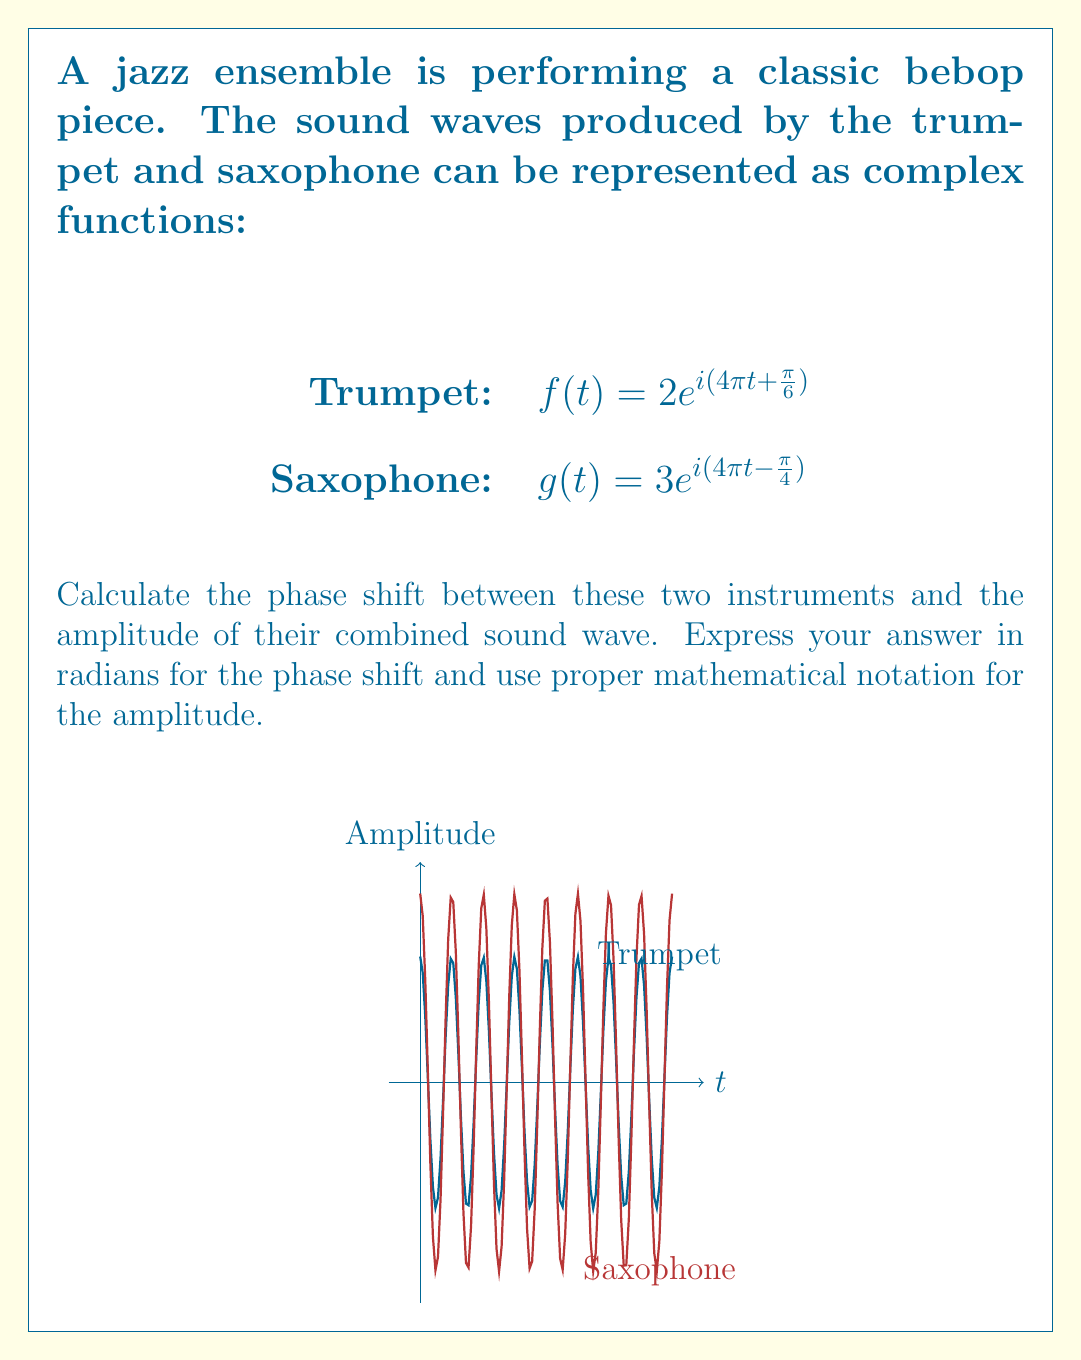Teach me how to tackle this problem. Let's approach this step-by-step:

1) Phase shift calculation:
   The phase of the trumpet wave is $4\pi t + \frac{\pi}{6}$
   The phase of the saxophone wave is $4\pi t - \frac{\pi}{4}$
   
   The phase shift is the difference between these phases:
   $$\Delta \phi = (\frac{\pi}{6}) - (-\frac{\pi}{4}) = \frac{\pi}{6} + \frac{\pi}{4} = \frac{5\pi}{12}$$

2) Amplitude calculation:
   To find the amplitude of the combined wave, we need to add the complex functions:
   
   $$h(t) = f(t) + g(t) = 2e^{i(4\pi t + \frac{\pi}{6})} + 3e^{i(4\pi t - \frac{\pi}{4})}$$
   
   We can factor out the common $e^{i4\pi t}$:
   
   $$h(t) = e^{i4\pi t}(2e^{i\frac{\pi}{6}} + 3e^{-i\frac{\pi}{4}})$$
   
   The amplitude of this combined wave is the magnitude of the complex number in parentheses:
   
   $$|2e^{i\frac{\pi}{6}} + 3e^{-i\frac{\pi}{4}}|$$
   
   We can calculate this using the formula $|a+bi| = \sqrt{a^2 + b^2}$:
   
   $$2e^{i\frac{\pi}{6}} = 2(\cos\frac{\pi}{6} + i\sin\frac{\pi}{6}) = \sqrt{3} + i$$
   $$3e^{-i\frac{\pi}{4}} = 3(\cos\frac{\pi}{4} - i\sin\frac{\pi}{4}) = \frac{3\sqrt{2}}{2} - \frac{3\sqrt{2}}{2}i$$
   
   Adding these:
   $$(\sqrt{3} + \frac{3\sqrt{2}}{2}) + (1 - \frac{3\sqrt{2}}{2})i$$
   
   The amplitude is:
   $$\sqrt{(\sqrt{3} + \frac{3\sqrt{2}}{2})^2 + (1 - \frac{3\sqrt{2}}{2})^2} \approx 3.86$$
Answer: Phase shift: $\frac{5\pi}{12}$ radians, Amplitude: $\sqrt{(\sqrt{3} + \frac{3\sqrt{2}}{2})^2 + (1 - \frac{3\sqrt{2}}{2})^2}$ 